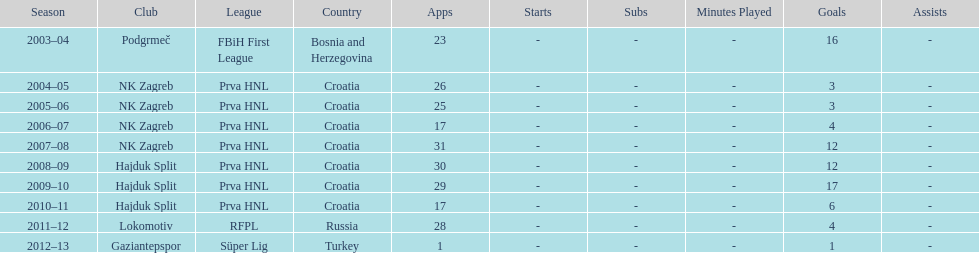What were the names of each club where more than 15 goals were scored in a single season? Podgrmeč, Hajduk Split. 